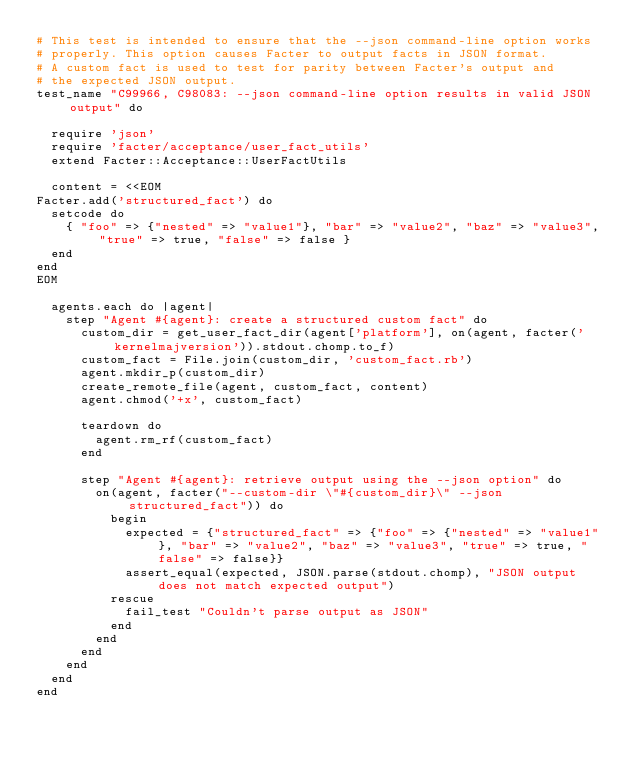<code> <loc_0><loc_0><loc_500><loc_500><_Ruby_># This test is intended to ensure that the --json command-line option works
# properly. This option causes Facter to output facts in JSON format.
# A custom fact is used to test for parity between Facter's output and
# the expected JSON output.
test_name "C99966, C98083: --json command-line option results in valid JSON output" do

  require 'json'
  require 'facter/acceptance/user_fact_utils'
  extend Facter::Acceptance::UserFactUtils

  content = <<EOM
Facter.add('structured_fact') do
  setcode do
    { "foo" => {"nested" => "value1"}, "bar" => "value2", "baz" => "value3", "true" => true, "false" => false }
  end
end
EOM

  agents.each do |agent|
    step "Agent #{agent}: create a structured custom fact" do
      custom_dir = get_user_fact_dir(agent['platform'], on(agent, facter('kernelmajversion')).stdout.chomp.to_f)
      custom_fact = File.join(custom_dir, 'custom_fact.rb')
      agent.mkdir_p(custom_dir)
      create_remote_file(agent, custom_fact, content)
      agent.chmod('+x', custom_fact)

      teardown do
        agent.rm_rf(custom_fact)
      end

      step "Agent #{agent}: retrieve output using the --json option" do
        on(agent, facter("--custom-dir \"#{custom_dir}\" --json structured_fact")) do
          begin
            expected = {"structured_fact" => {"foo" => {"nested" => "value1"}, "bar" => "value2", "baz" => "value3", "true" => true, "false" => false}}
            assert_equal(expected, JSON.parse(stdout.chomp), "JSON output does not match expected output")
          rescue
            fail_test "Couldn't parse output as JSON"
          end
        end
      end
    end
  end
end
</code> 